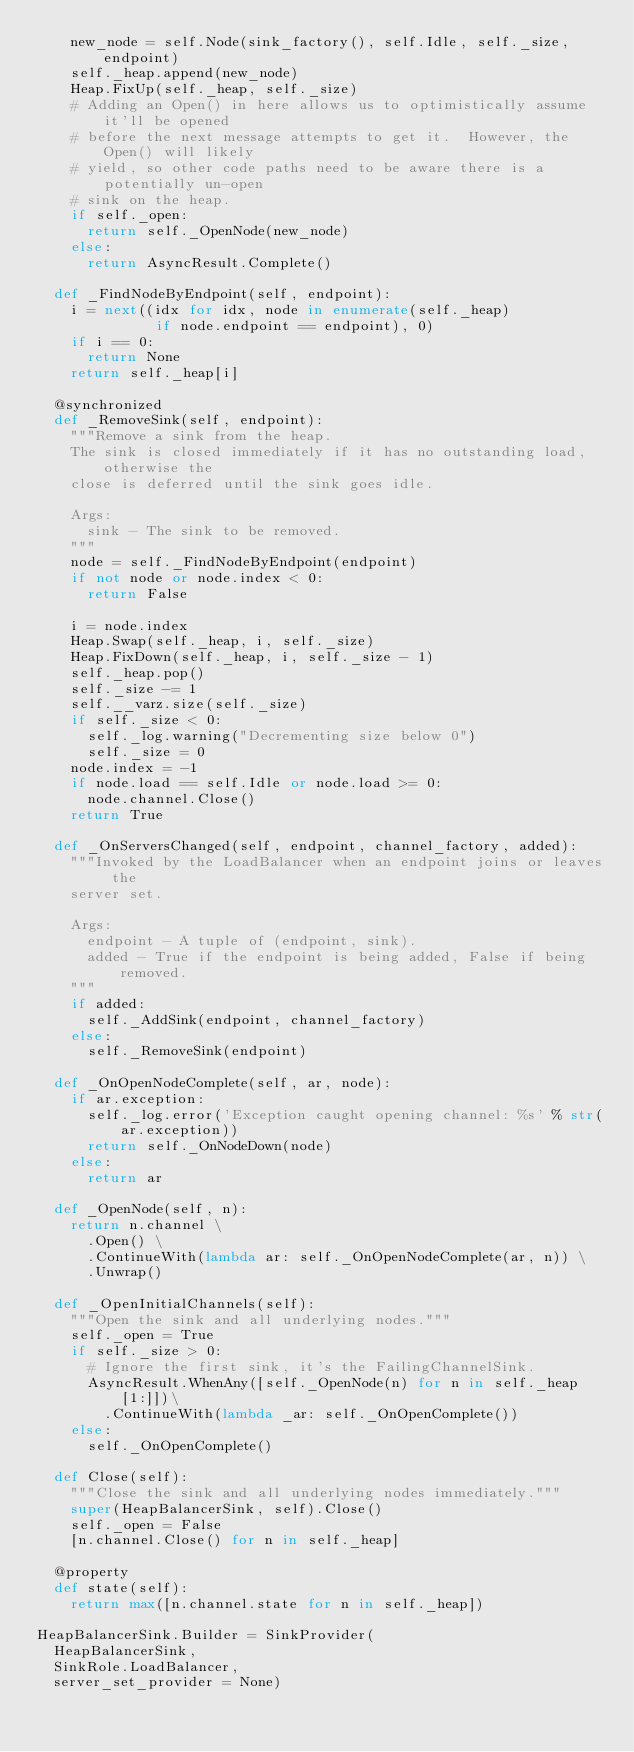<code> <loc_0><loc_0><loc_500><loc_500><_Python_>    new_node = self.Node(sink_factory(), self.Idle, self._size, endpoint)
    self._heap.append(new_node)
    Heap.FixUp(self._heap, self._size)
    # Adding an Open() in here allows us to optimistically assume it'll be opened
    # before the next message attempts to get it.  However, the Open() will likely
    # yield, so other code paths need to be aware there is a potentially un-open
    # sink on the heap.
    if self._open:
      return self._OpenNode(new_node)
    else:
      return AsyncResult.Complete()

  def _FindNodeByEndpoint(self, endpoint):
    i = next((idx for idx, node in enumerate(self._heap)
              if node.endpoint == endpoint), 0)
    if i == 0:
      return None
    return self._heap[i]

  @synchronized
  def _RemoveSink(self, endpoint):
    """Remove a sink from the heap.
    The sink is closed immediately if it has no outstanding load, otherwise the
    close is deferred until the sink goes idle.

    Args:
      sink - The sink to be removed.
    """
    node = self._FindNodeByEndpoint(endpoint)
    if not node or node.index < 0:
      return False

    i = node.index
    Heap.Swap(self._heap, i, self._size)
    Heap.FixDown(self._heap, i, self._size - 1)
    self._heap.pop()
    self._size -= 1
    self.__varz.size(self._size)
    if self._size < 0:
      self._log.warning("Decrementing size below 0")
      self._size = 0
    node.index = -1
    if node.load == self.Idle or node.load >= 0:
      node.channel.Close()
    return True

  def _OnServersChanged(self, endpoint, channel_factory, added):
    """Invoked by the LoadBalancer when an endpoint joins or leaves the
    server set.

    Args:
      endpoint - A tuple of (endpoint, sink).
      added - True if the endpoint is being added, False if being removed.
    """
    if added:
      self._AddSink(endpoint, channel_factory)
    else:
      self._RemoveSink(endpoint)

  def _OnOpenNodeComplete(self, ar, node):
    if ar.exception:
      self._log.error('Exception caught opening channel: %s' % str(ar.exception))
      return self._OnNodeDown(node)
    else:
      return ar

  def _OpenNode(self, n):
    return n.channel \
      .Open() \
      .ContinueWith(lambda ar: self._OnOpenNodeComplete(ar, n)) \
      .Unwrap()

  def _OpenInitialChannels(self):
    """Open the sink and all underlying nodes."""
    self._open = True
    if self._size > 0:
      # Ignore the first sink, it's the FailingChannelSink.
      AsyncResult.WhenAny([self._OpenNode(n) for n in self._heap[1:]])\
        .ContinueWith(lambda _ar: self._OnOpenComplete())
    else:
      self._OnOpenComplete()

  def Close(self):
    """Close the sink and all underlying nodes immediately."""
    super(HeapBalancerSink, self).Close()
    self._open = False
    [n.channel.Close() for n in self._heap]

  @property
  def state(self):
    return max([n.channel.state for n in self._heap])

HeapBalancerSink.Builder = SinkProvider(
  HeapBalancerSink,
  SinkRole.LoadBalancer,
  server_set_provider = None)
</code> 